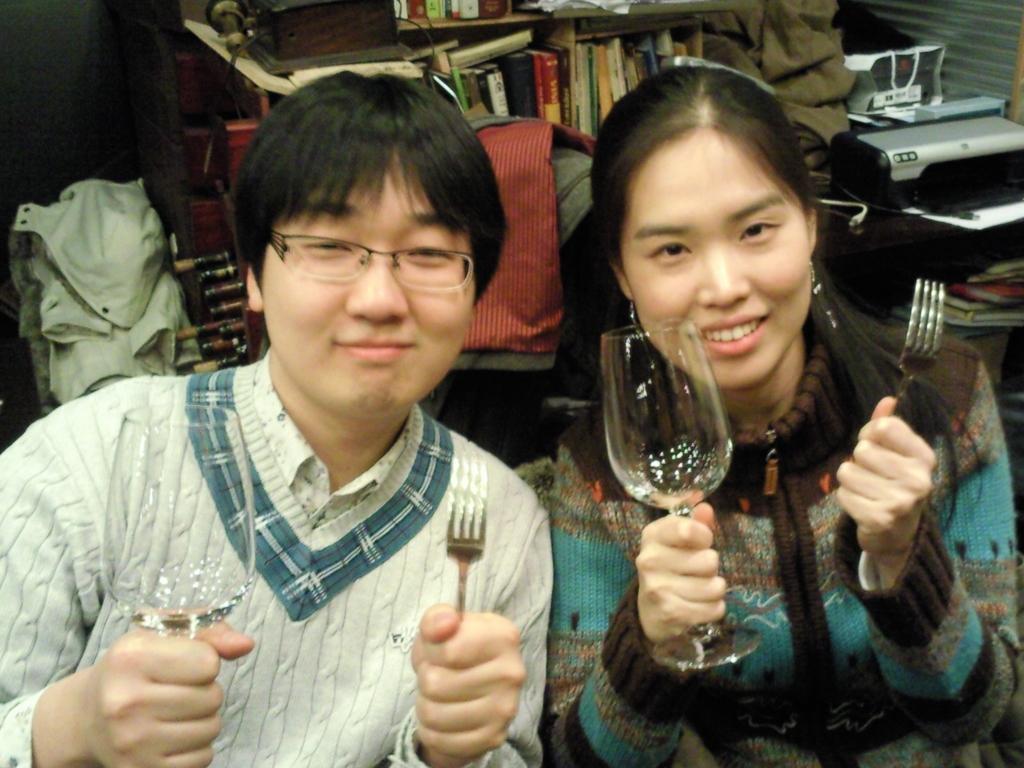Describe this image in one or two sentences. In the image we can see two person. They were smiling and holding glass and fork. In the background we can see shelf,books,table,chair etc. 